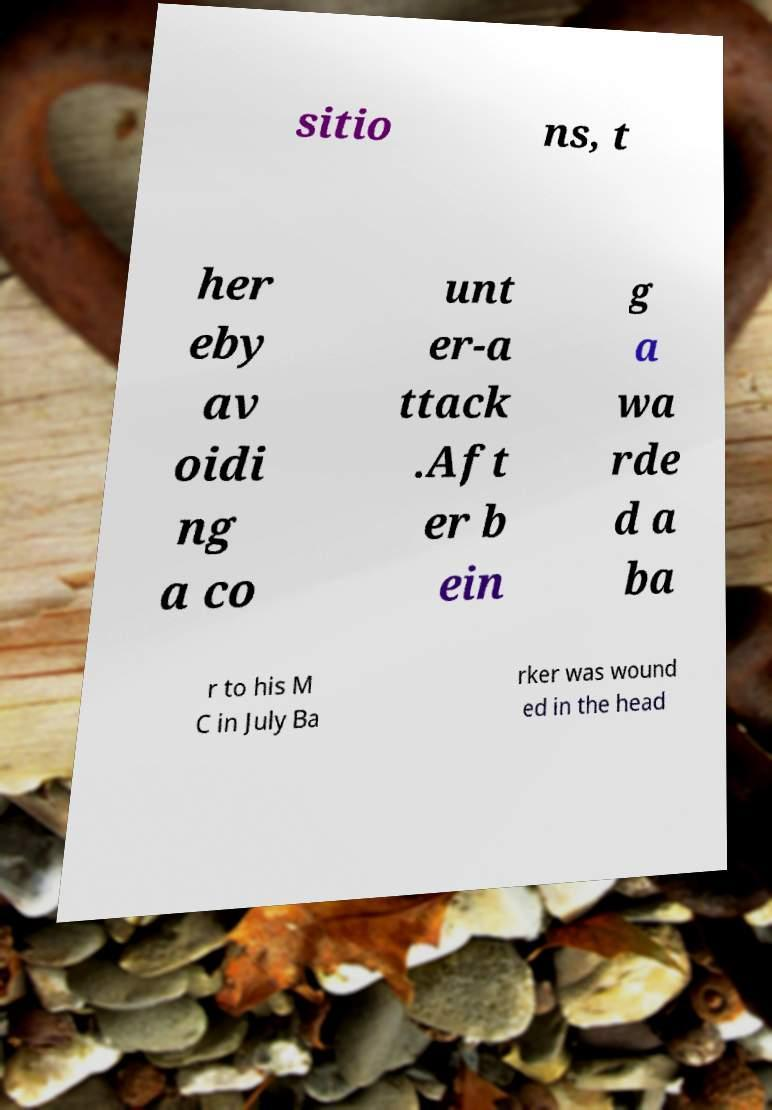Can you accurately transcribe the text from the provided image for me? sitio ns, t her eby av oidi ng a co unt er-a ttack .Aft er b ein g a wa rde d a ba r to his M C in July Ba rker was wound ed in the head 